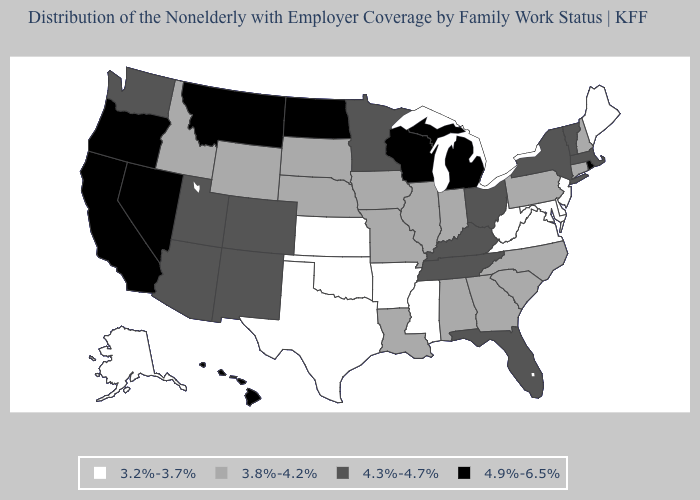Name the states that have a value in the range 4.3%-4.7%?
Concise answer only. Arizona, Colorado, Florida, Kentucky, Massachusetts, Minnesota, New Mexico, New York, Ohio, Tennessee, Utah, Vermont, Washington. Which states have the highest value in the USA?
Keep it brief. California, Hawaii, Michigan, Montana, Nevada, North Dakota, Oregon, Rhode Island, Wisconsin. What is the value of Oklahoma?
Concise answer only. 3.2%-3.7%. Does Louisiana have a higher value than Alaska?
Give a very brief answer. Yes. Name the states that have a value in the range 3.2%-3.7%?
Write a very short answer. Alaska, Arkansas, Delaware, Kansas, Maine, Maryland, Mississippi, New Jersey, Oklahoma, Texas, Virginia, West Virginia. What is the lowest value in states that border Oregon?
Short answer required. 3.8%-4.2%. Name the states that have a value in the range 4.9%-6.5%?
Be succinct. California, Hawaii, Michigan, Montana, Nevada, North Dakota, Oregon, Rhode Island, Wisconsin. What is the value of New Hampshire?
Be succinct. 3.8%-4.2%. Does Kansas have a lower value than Connecticut?
Short answer required. Yes. What is the value of New Jersey?
Short answer required. 3.2%-3.7%. Among the states that border Minnesota , does Iowa have the highest value?
Be succinct. No. Among the states that border Oklahoma , which have the lowest value?
Short answer required. Arkansas, Kansas, Texas. Among the states that border New Mexico , does Texas have the highest value?
Write a very short answer. No. Does New Mexico have a higher value than Pennsylvania?
Concise answer only. Yes. What is the value of Maine?
Short answer required. 3.2%-3.7%. 